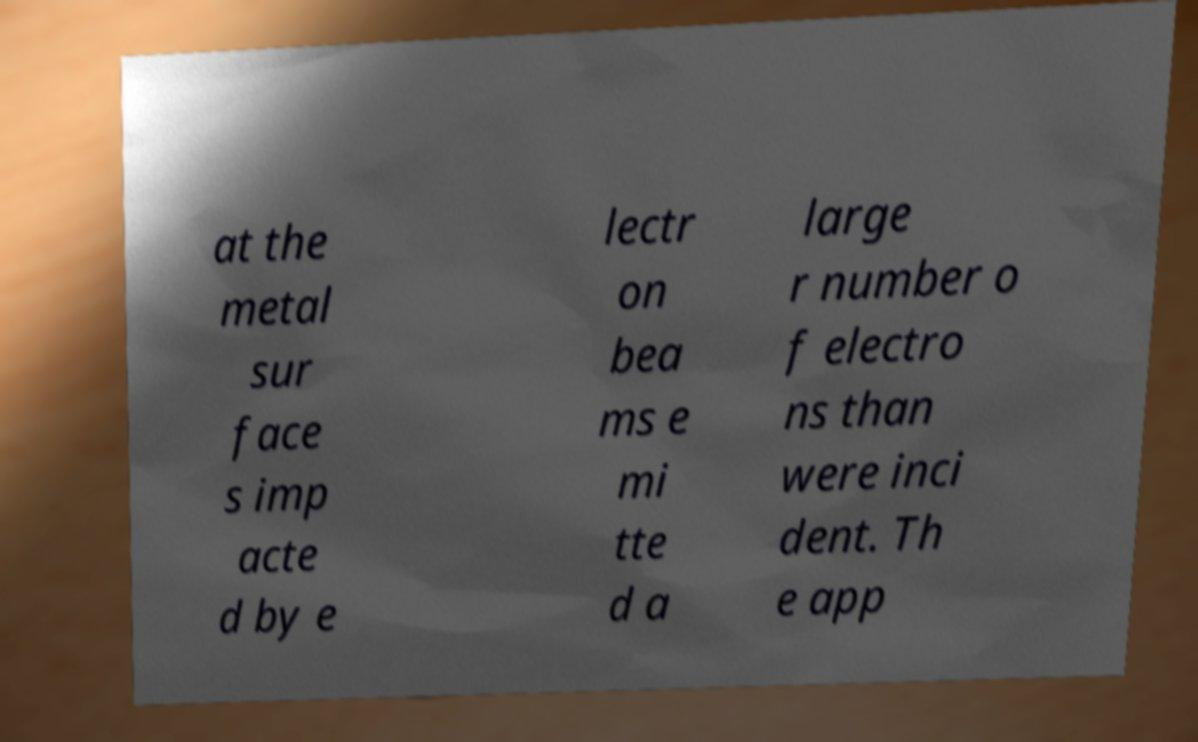Could you assist in decoding the text presented in this image and type it out clearly? at the metal sur face s imp acte d by e lectr on bea ms e mi tte d a large r number o f electro ns than were inci dent. Th e app 